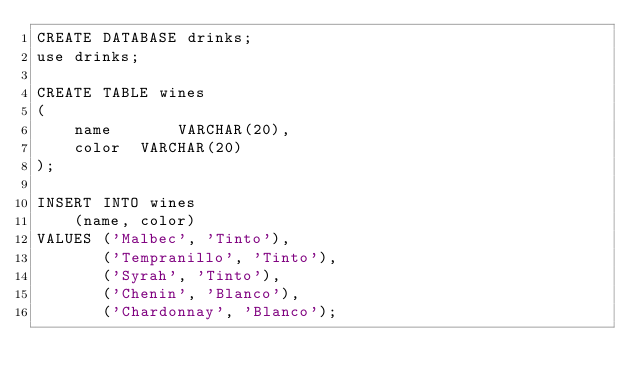Convert code to text. <code><loc_0><loc_0><loc_500><loc_500><_SQL_>CREATE DATABASE drinks;
use drinks;

CREATE TABLE wines
(
    name       VARCHAR(20),
    color  VARCHAR(20)
);

INSERT INTO wines
    (name, color)
VALUES ('Malbec', 'Tinto'),
       ('Tempranillo', 'Tinto'),
       ('Syrah', 'Tinto'),
       ('Chenin', 'Blanco'),
       ('Chardonnay', 'Blanco');    </code> 